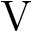Convert formula to latex. <formula><loc_0><loc_0><loc_500><loc_500>V</formula> 